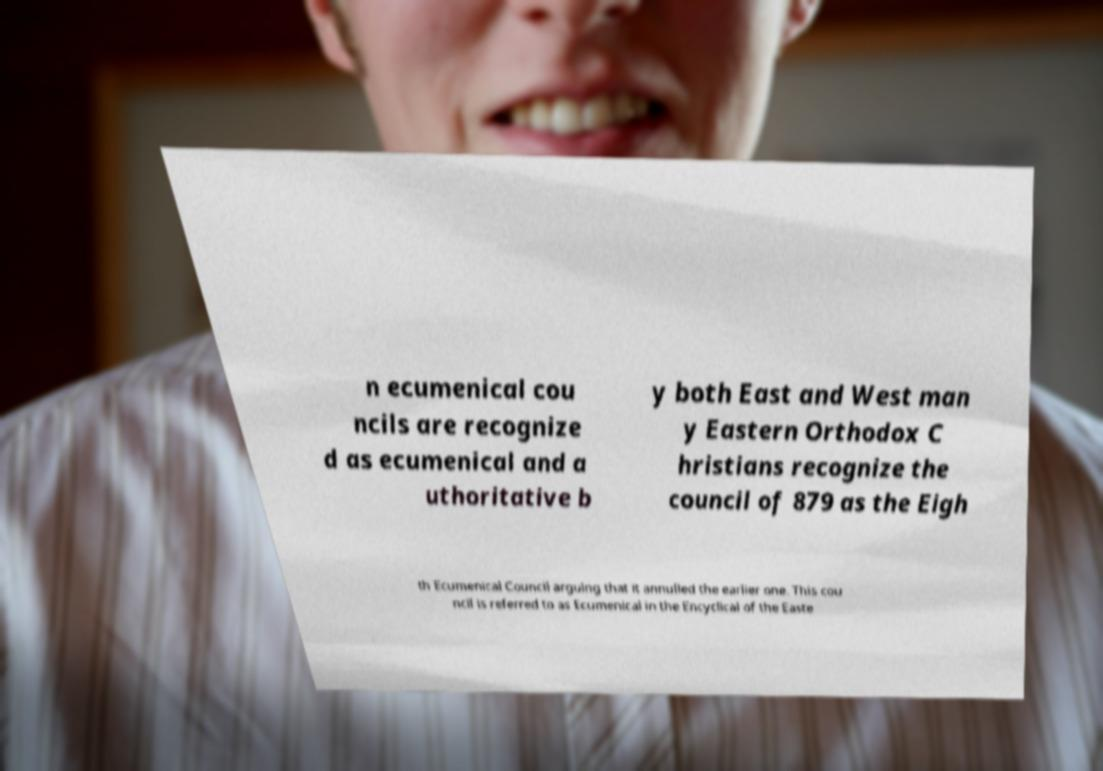Can you accurately transcribe the text from the provided image for me? n ecumenical cou ncils are recognize d as ecumenical and a uthoritative b y both East and West man y Eastern Orthodox C hristians recognize the council of 879 as the Eigh th Ecumenical Council arguing that it annulled the earlier one. This cou ncil is referred to as Ecumenical in the Encyclical of the Easte 